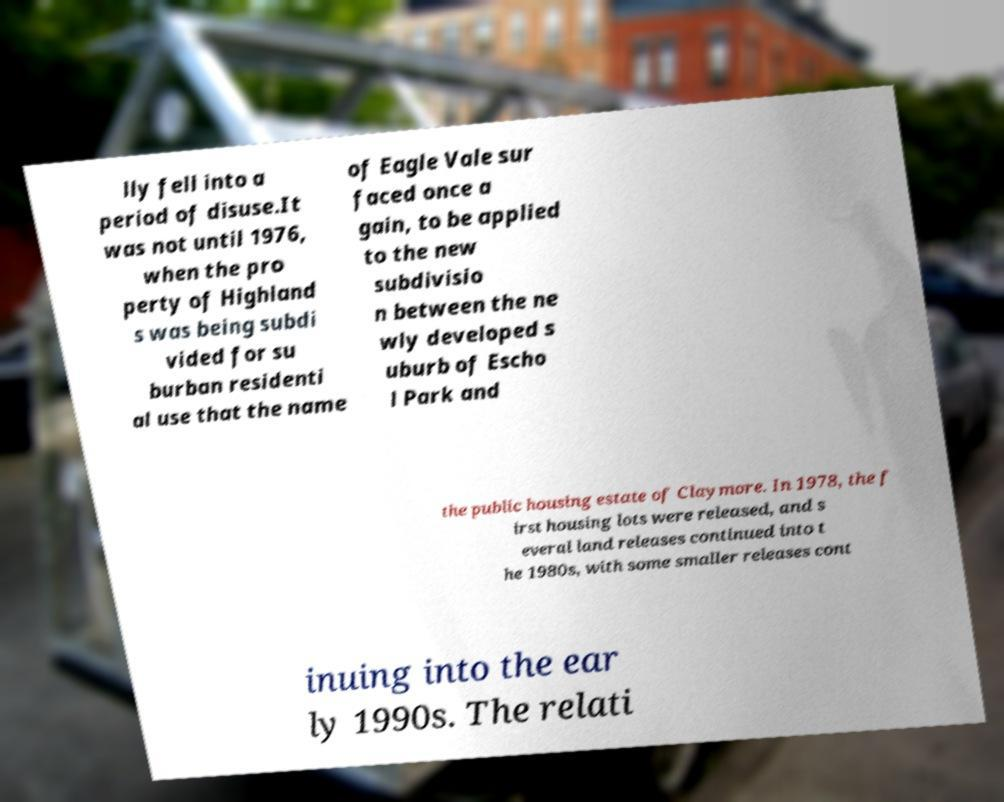Please identify and transcribe the text found in this image. lly fell into a period of disuse.It was not until 1976, when the pro perty of Highland s was being subdi vided for su burban residenti al use that the name of Eagle Vale sur faced once a gain, to be applied to the new subdivisio n between the ne wly developed s uburb of Escho l Park and the public housing estate of Claymore. In 1978, the f irst housing lots were released, and s everal land releases continued into t he 1980s, with some smaller releases cont inuing into the ear ly 1990s. The relati 